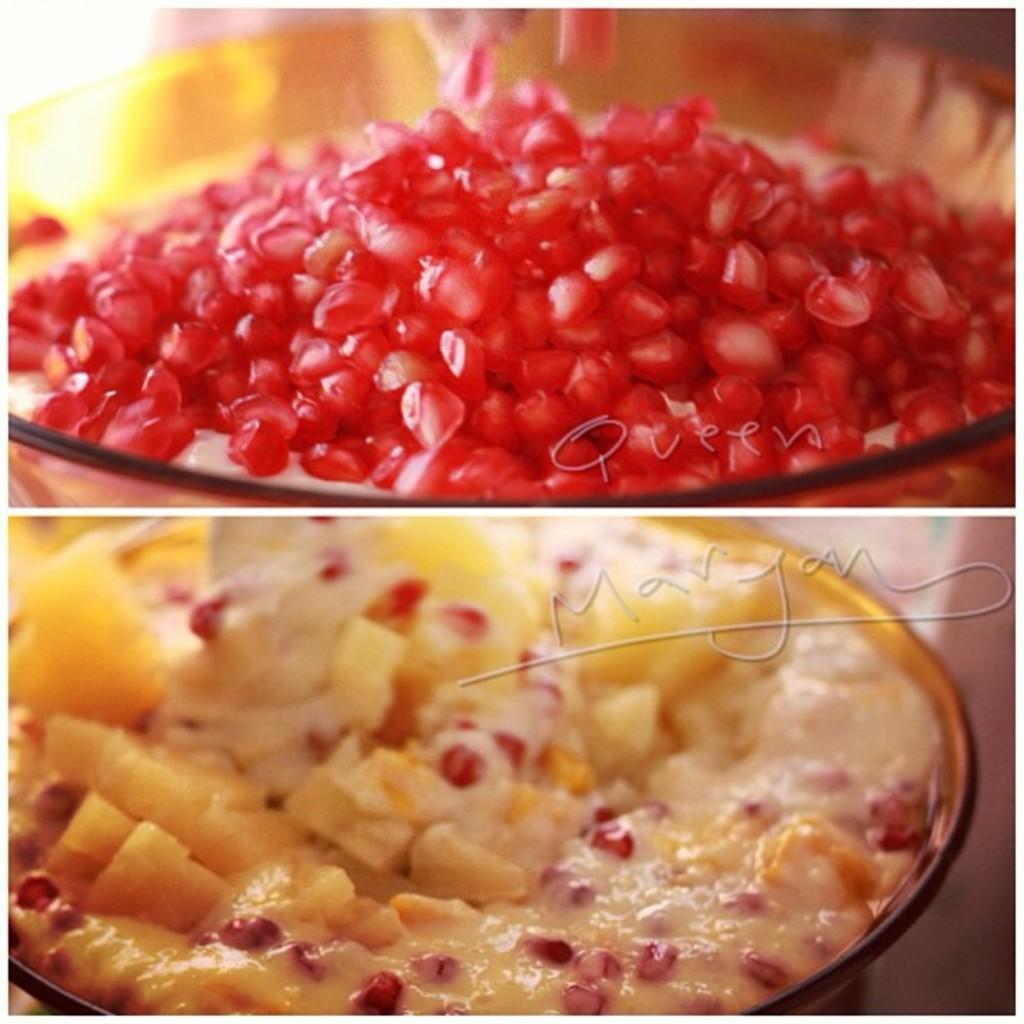What is the format of the image? The image is a collage of multiple pictures. What type of food items can be seen in the collage? There are fruits and bowls containing food in the collage. Is there any text present in the image? Yes, there is text present in the collage. What type of amusement can be seen in the collage? There is no amusement present in the collage; it primarily features food items and text. Can you see a knife being used in the collage? There is no knife visible in the collage. 